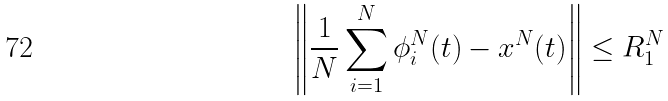<formula> <loc_0><loc_0><loc_500><loc_500>\left \| \frac { 1 } { N } \sum _ { i = 1 } ^ { N } \phi _ { i } ^ { N } ( t ) - x ^ { N } ( t ) \right \| \leq R _ { 1 } ^ { N }</formula> 